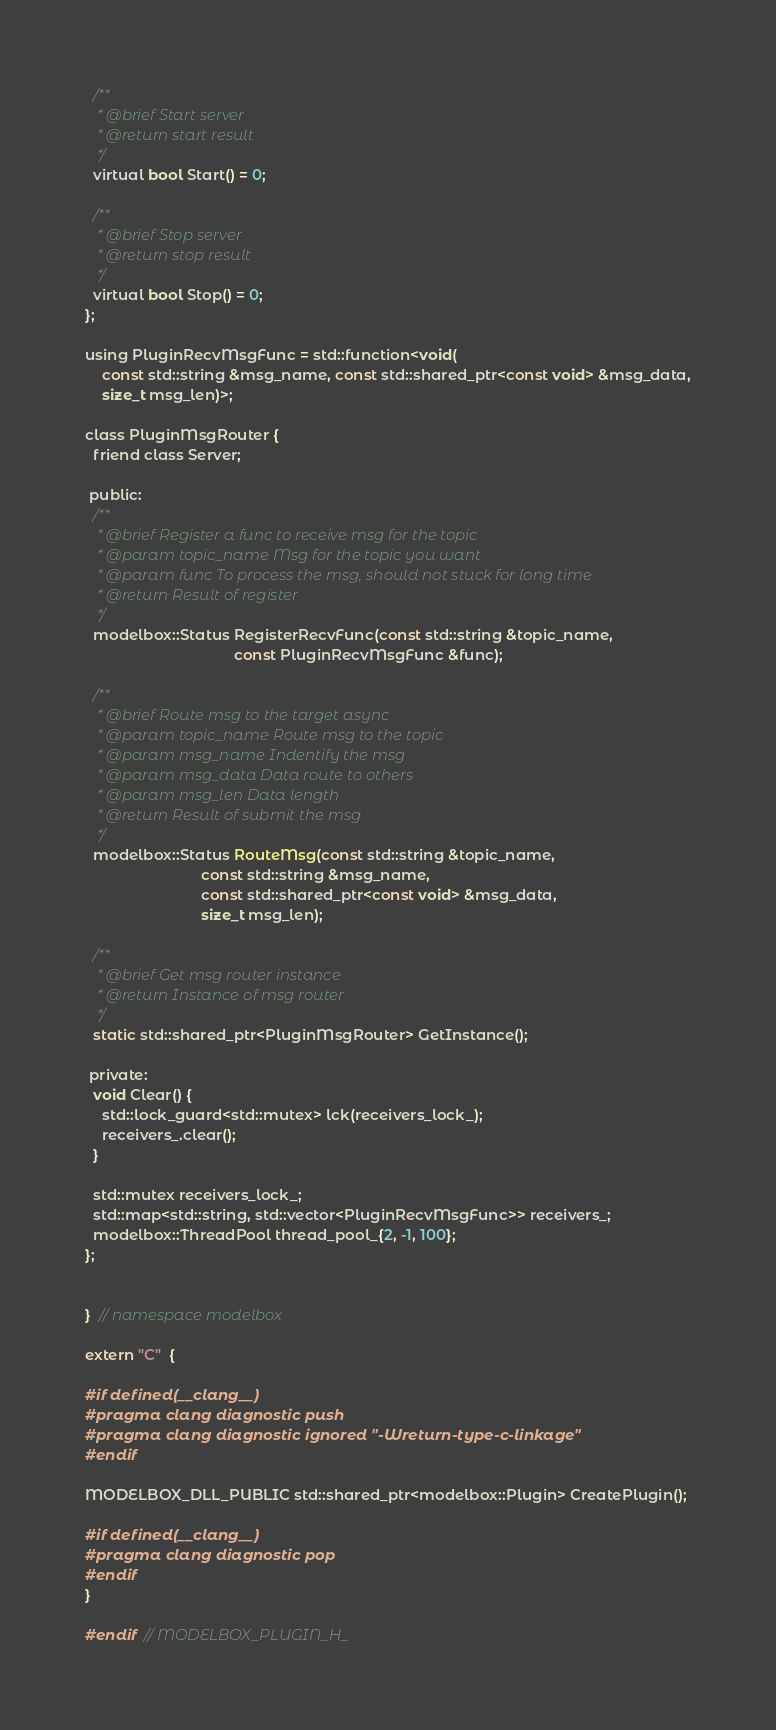<code> <loc_0><loc_0><loc_500><loc_500><_C_>  /**
   * @brief Start server
   * @return start result
   */
  virtual bool Start() = 0;

  /**
   * @brief Stop server
   * @return stop result
   */
  virtual bool Stop() = 0;
};

using PluginRecvMsgFunc = std::function<void(
    const std::string &msg_name, const std::shared_ptr<const void> &msg_data,
    size_t msg_len)>;

class PluginMsgRouter {
  friend class Server;

 public:
  /**
   * @brief Register a func to receive msg for the topic
   * @param topic_name Msg for the topic you want
   * @param func To process the msg, should not stuck for long time
   * @return Result of register
   */
  modelbox::Status RegisterRecvFunc(const std::string &topic_name,
                                    const PluginRecvMsgFunc &func);

  /**
   * @brief Route msg to the target async
   * @param topic_name Route msg to the topic
   * @param msg_name Indentify the msg
   * @param msg_data Data route to others
   * @param msg_len Data length
   * @return Result of submit the msg
   */
  modelbox::Status RouteMsg(const std::string &topic_name,
                            const std::string &msg_name,
                            const std::shared_ptr<const void> &msg_data,
                            size_t msg_len);

  /**
   * @brief Get msg router instance
   * @return Instance of msg router
   */
  static std::shared_ptr<PluginMsgRouter> GetInstance();

 private:
  void Clear() {
    std::lock_guard<std::mutex> lck(receivers_lock_);
    receivers_.clear();
  }

  std::mutex receivers_lock_;
  std::map<std::string, std::vector<PluginRecvMsgFunc>> receivers_;
  modelbox::ThreadPool thread_pool_{2, -1, 100};
};


}  // namespace modelbox

extern "C"  {

#if defined(__clang__)
#pragma clang diagnostic push
#pragma clang diagnostic ignored "-Wreturn-type-c-linkage"
#endif

MODELBOX_DLL_PUBLIC std::shared_ptr<modelbox::Plugin> CreatePlugin();

#if defined(__clang__)
#pragma clang diagnostic pop
#endif
}

#endif  // MODELBOX_PLUGIN_H_
</code> 